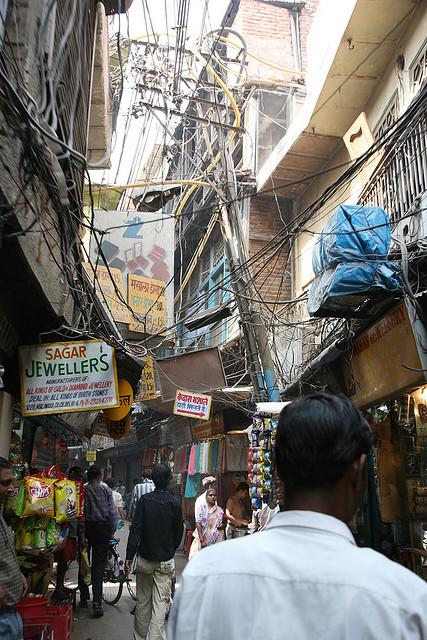Where is this photo taken?
Quick response, please. India. What does the sign say in red?
Concise answer only. Sagar. Is it daytime?
Quick response, please. Yes. 